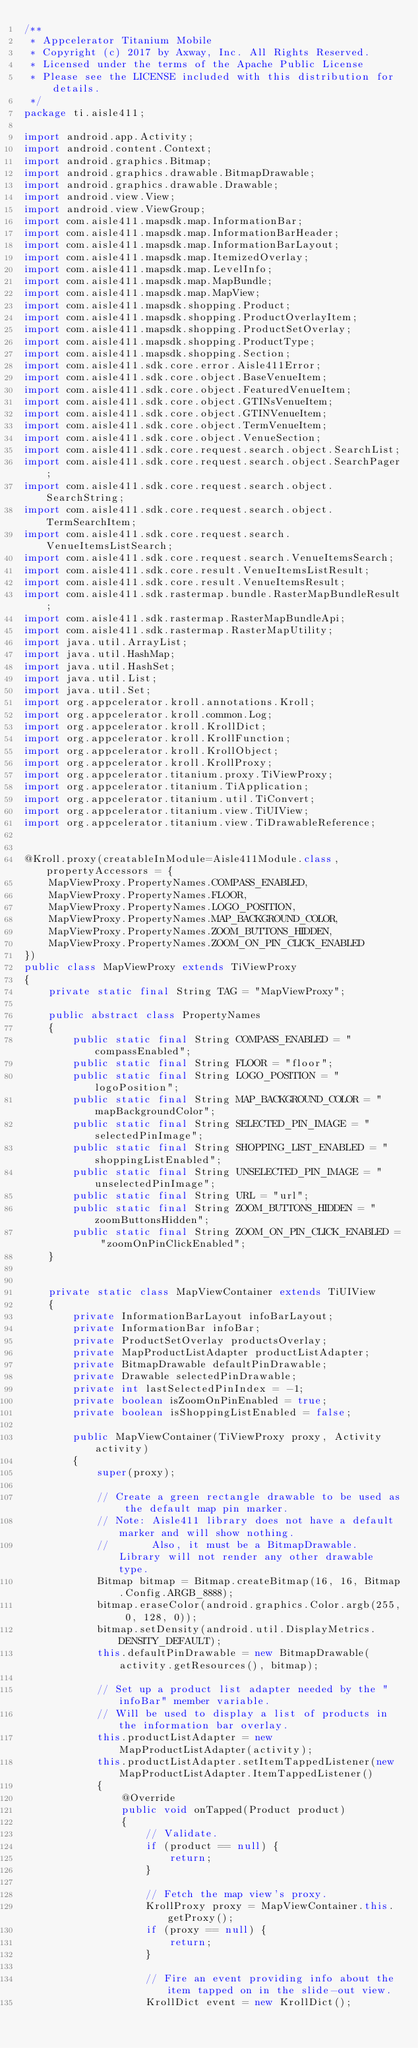<code> <loc_0><loc_0><loc_500><loc_500><_Java_>/**
 * Appcelerator Titanium Mobile
 * Copyright (c) 2017 by Axway, Inc. All Rights Reserved.
 * Licensed under the terms of the Apache Public License
 * Please see the LICENSE included with this distribution for details.
 */
package ti.aisle411;

import android.app.Activity;
import android.content.Context;
import android.graphics.Bitmap;
import android.graphics.drawable.BitmapDrawable;
import android.graphics.drawable.Drawable;
import android.view.View;
import android.view.ViewGroup;
import com.aisle411.mapsdk.map.InformationBar;
import com.aisle411.mapsdk.map.InformationBarHeader;
import com.aisle411.mapsdk.map.InformationBarLayout;
import com.aisle411.mapsdk.map.ItemizedOverlay;
import com.aisle411.mapsdk.map.LevelInfo;
import com.aisle411.mapsdk.map.MapBundle;
import com.aisle411.mapsdk.map.MapView;
import com.aisle411.mapsdk.shopping.Product;
import com.aisle411.mapsdk.shopping.ProductOverlayItem;
import com.aisle411.mapsdk.shopping.ProductSetOverlay;
import com.aisle411.mapsdk.shopping.ProductType;
import com.aisle411.mapsdk.shopping.Section;
import com.aisle411.sdk.core.error.Aisle411Error;
import com.aisle411.sdk.core.object.BaseVenueItem;
import com.aisle411.sdk.core.object.FeaturedVenueItem;
import com.aisle411.sdk.core.object.GTINsVenueItem;
import com.aisle411.sdk.core.object.GTINVenueItem;
import com.aisle411.sdk.core.object.TermVenueItem;
import com.aisle411.sdk.core.object.VenueSection;
import com.aisle411.sdk.core.request.search.object.SearchList;
import com.aisle411.sdk.core.request.search.object.SearchPager;
import com.aisle411.sdk.core.request.search.object.SearchString;
import com.aisle411.sdk.core.request.search.object.TermSearchItem;
import com.aisle411.sdk.core.request.search.VenueItemsListSearch;
import com.aisle411.sdk.core.request.search.VenueItemsSearch;
import com.aisle411.sdk.core.result.VenueItemsListResult;
import com.aisle411.sdk.core.result.VenueItemsResult;
import com.aisle411.sdk.rastermap.bundle.RasterMapBundleResult;
import com.aisle411.sdk.rastermap.RasterMapBundleApi;
import com.aisle411.sdk.rastermap.RasterMapUtility;
import java.util.ArrayList;
import java.util.HashMap;
import java.util.HashSet;
import java.util.List;
import java.util.Set;
import org.appcelerator.kroll.annotations.Kroll;
import org.appcelerator.kroll.common.Log;
import org.appcelerator.kroll.KrollDict;
import org.appcelerator.kroll.KrollFunction;
import org.appcelerator.kroll.KrollObject;
import org.appcelerator.kroll.KrollProxy;
import org.appcelerator.titanium.proxy.TiViewProxy;
import org.appcelerator.titanium.TiApplication;
import org.appcelerator.titanium.util.TiConvert;
import org.appcelerator.titanium.view.TiUIView;
import org.appcelerator.titanium.view.TiDrawableReference;


@Kroll.proxy(creatableInModule=Aisle411Module.class, propertyAccessors = {
	MapViewProxy.PropertyNames.COMPASS_ENABLED,
	MapViewProxy.PropertyNames.FLOOR,
	MapViewProxy.PropertyNames.LOGO_POSITION,
	MapViewProxy.PropertyNames.MAP_BACKGROUND_COLOR,
	MapViewProxy.PropertyNames.ZOOM_BUTTONS_HIDDEN,
	MapViewProxy.PropertyNames.ZOOM_ON_PIN_CLICK_ENABLED
})
public class MapViewProxy extends TiViewProxy
{
	private static final String TAG = "MapViewProxy";

	public abstract class PropertyNames
	{
		public static final String COMPASS_ENABLED = "compassEnabled";
		public static final String FLOOR = "floor";
		public static final String LOGO_POSITION = "logoPosition";
		public static final String MAP_BACKGROUND_COLOR = "mapBackgroundColor";
		public static final String SELECTED_PIN_IMAGE = "selectedPinImage";
		public static final String SHOPPING_LIST_ENABLED = "shoppingListEnabled";
		public static final String UNSELECTED_PIN_IMAGE = "unselectedPinImage";
		public static final String URL = "url";
		public static final String ZOOM_BUTTONS_HIDDEN = "zoomButtonsHidden";
		public static final String ZOOM_ON_PIN_CLICK_ENABLED = "zoomOnPinClickEnabled";
	}


	private static class MapViewContainer extends TiUIView
	{
		private InformationBarLayout infoBarLayout;
		private InformationBar infoBar;
		private ProductSetOverlay productsOverlay;
		private MapProductListAdapter productListAdapter;
		private BitmapDrawable defaultPinDrawable;
		private Drawable selectedPinDrawable;
		private int lastSelectedPinIndex = -1;
		private boolean isZoomOnPinEnabled = true;
		private boolean isShoppingListEnabled = false;

		public MapViewContainer(TiViewProxy proxy, Activity activity)
		{
			super(proxy);

			// Create a green rectangle drawable to be used as the default map pin marker.
			// Note: Aisle411 library does not have a default marker and will show nothing.
			//       Also, it must be a BitmapDrawable. Library will not render any other drawable type.
			Bitmap bitmap = Bitmap.createBitmap(16, 16, Bitmap.Config.ARGB_8888);
			bitmap.eraseColor(android.graphics.Color.argb(255, 0, 128, 0));
			bitmap.setDensity(android.util.DisplayMetrics.DENSITY_DEFAULT);
			this.defaultPinDrawable = new BitmapDrawable(activity.getResources(), bitmap);

			// Set up a product list adapter needed by the "infoBar" member variable.
			// Will be used to display a list of products in the information bar overlay.
			this.productListAdapter = new MapProductListAdapter(activity);
			this.productListAdapter.setItemTappedListener(new MapProductListAdapter.ItemTappedListener()
			{
				@Override
				public void onTapped(Product product)
				{
					// Validate.
					if (product == null) {
						return;
					}

					// Fetch the map view's proxy.
					KrollProxy proxy = MapViewContainer.this.getProxy();
					if (proxy == null) {
						return;
					}

					// Fire an event providing info about the item tapped on in the slide-out view.
					KrollDict event = new KrollDict();</code> 